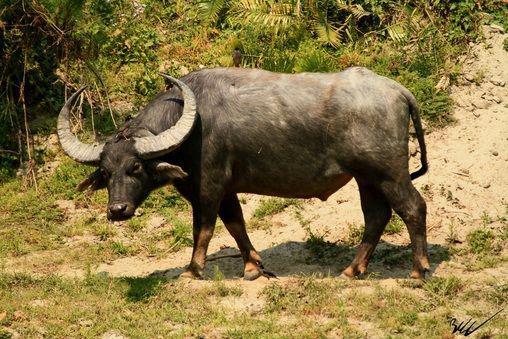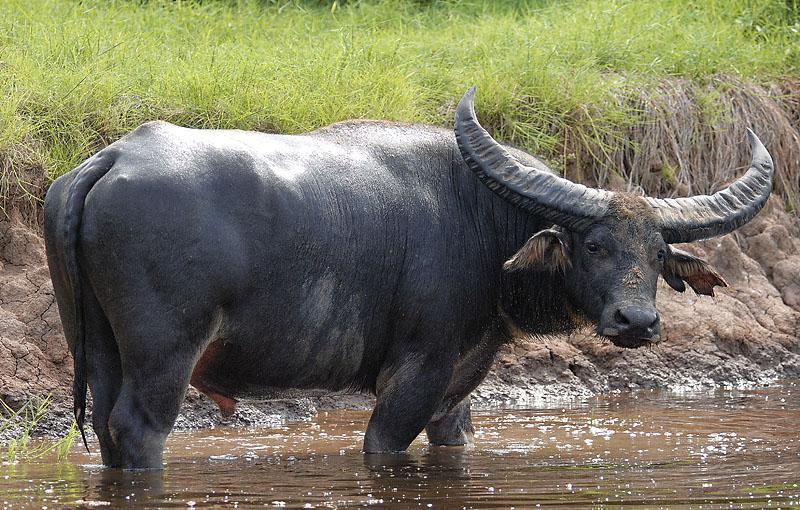The first image is the image on the left, the second image is the image on the right. Examine the images to the left and right. Is the description "In at least one image,there is a single black bull with two long horns facing left on grass and dirt." accurate? Answer yes or no. Yes. The first image is the image on the left, the second image is the image on the right. Assess this claim about the two images: "There are exactly two water buffalos with one of them facing leftward.". Correct or not? Answer yes or no. Yes. 